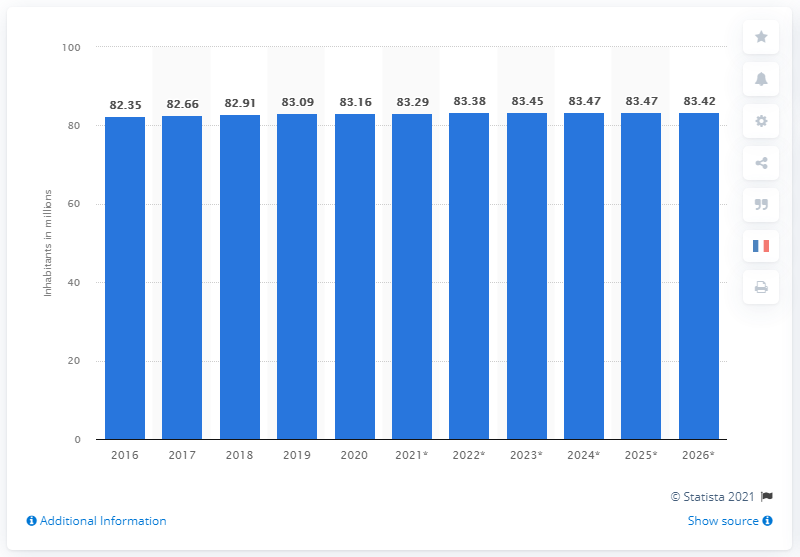Mention a couple of crucial points in this snapshot. The expected population of Germany in 2026 is projected to remain at 83.42 million. As of 2026, the population of Germany is expected to remain around 83.42 people. 